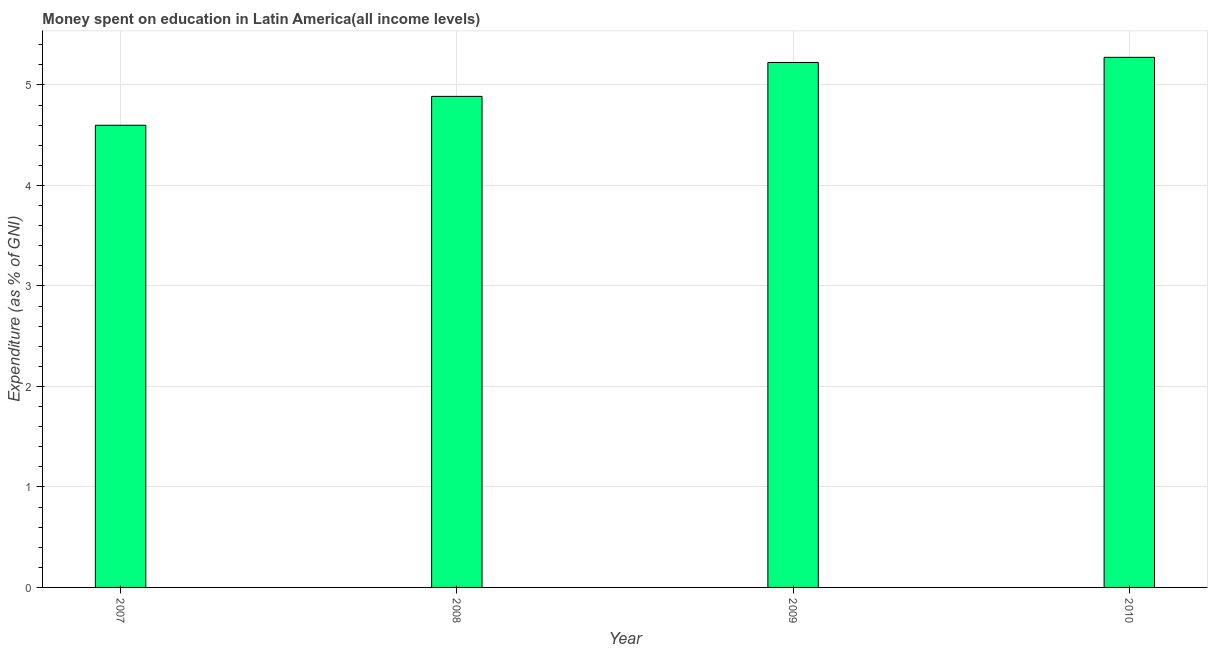Does the graph contain grids?
Provide a succinct answer. Yes. What is the title of the graph?
Give a very brief answer. Money spent on education in Latin America(all income levels). What is the label or title of the Y-axis?
Your response must be concise. Expenditure (as % of GNI). What is the expenditure on education in 2007?
Your answer should be compact. 4.6. Across all years, what is the maximum expenditure on education?
Offer a terse response. 5.28. Across all years, what is the minimum expenditure on education?
Your answer should be very brief. 4.6. What is the sum of the expenditure on education?
Provide a succinct answer. 19.99. What is the difference between the expenditure on education in 2007 and 2008?
Your answer should be very brief. -0.29. What is the average expenditure on education per year?
Offer a terse response. 5. What is the median expenditure on education?
Ensure brevity in your answer.  5.06. In how many years, is the expenditure on education greater than 0.8 %?
Keep it short and to the point. 4. What is the ratio of the expenditure on education in 2008 to that in 2009?
Your response must be concise. 0.94. Is the expenditure on education in 2007 less than that in 2009?
Ensure brevity in your answer.  Yes. What is the difference between the highest and the second highest expenditure on education?
Your answer should be compact. 0.05. Is the sum of the expenditure on education in 2007 and 2009 greater than the maximum expenditure on education across all years?
Give a very brief answer. Yes. What is the difference between the highest and the lowest expenditure on education?
Provide a short and direct response. 0.68. Are all the bars in the graph horizontal?
Your answer should be very brief. No. How many years are there in the graph?
Provide a succinct answer. 4. What is the Expenditure (as % of GNI) in 2007?
Your answer should be very brief. 4.6. What is the Expenditure (as % of GNI) of 2008?
Make the answer very short. 4.89. What is the Expenditure (as % of GNI) in 2009?
Your answer should be very brief. 5.22. What is the Expenditure (as % of GNI) in 2010?
Your answer should be compact. 5.28. What is the difference between the Expenditure (as % of GNI) in 2007 and 2008?
Your answer should be very brief. -0.29. What is the difference between the Expenditure (as % of GNI) in 2007 and 2009?
Offer a very short reply. -0.62. What is the difference between the Expenditure (as % of GNI) in 2007 and 2010?
Ensure brevity in your answer.  -0.68. What is the difference between the Expenditure (as % of GNI) in 2008 and 2009?
Ensure brevity in your answer.  -0.34. What is the difference between the Expenditure (as % of GNI) in 2008 and 2010?
Give a very brief answer. -0.39. What is the difference between the Expenditure (as % of GNI) in 2009 and 2010?
Make the answer very short. -0.05. What is the ratio of the Expenditure (as % of GNI) in 2007 to that in 2008?
Make the answer very short. 0.94. What is the ratio of the Expenditure (as % of GNI) in 2007 to that in 2009?
Make the answer very short. 0.88. What is the ratio of the Expenditure (as % of GNI) in 2007 to that in 2010?
Your answer should be very brief. 0.87. What is the ratio of the Expenditure (as % of GNI) in 2008 to that in 2009?
Make the answer very short. 0.94. What is the ratio of the Expenditure (as % of GNI) in 2008 to that in 2010?
Make the answer very short. 0.93. What is the ratio of the Expenditure (as % of GNI) in 2009 to that in 2010?
Your response must be concise. 0.99. 